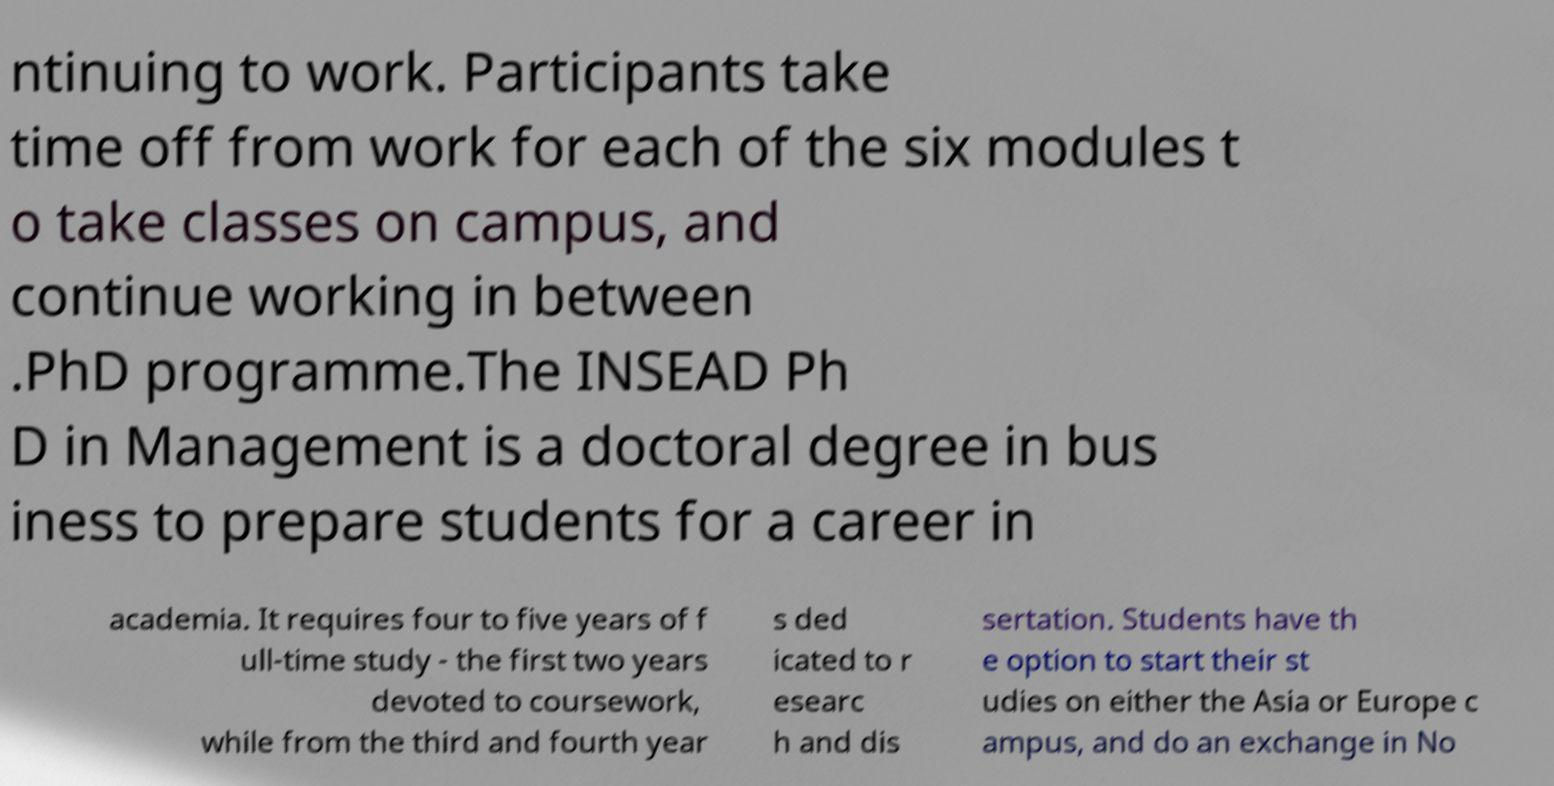Please read and relay the text visible in this image. What does it say? ntinuing to work. Participants take time off from work for each of the six modules t o take classes on campus, and continue working in between .PhD programme.The INSEAD Ph D in Management is a doctoral degree in bus iness to prepare students for a career in academia. It requires four to five years of f ull-time study - the first two years devoted to coursework, while from the third and fourth year s ded icated to r esearc h and dis sertation. Students have th e option to start their st udies on either the Asia or Europe c ampus, and do an exchange in No 